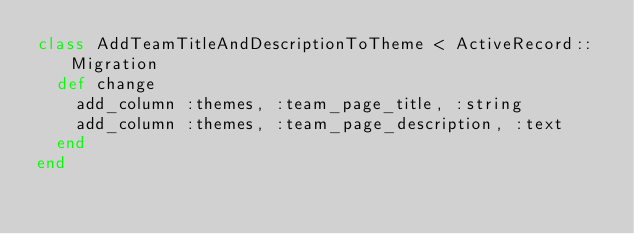Convert code to text. <code><loc_0><loc_0><loc_500><loc_500><_Ruby_>class AddTeamTitleAndDescriptionToTheme < ActiveRecord::Migration
  def change
    add_column :themes, :team_page_title, :string
    add_column :themes, :team_page_description, :text
  end
end
</code> 